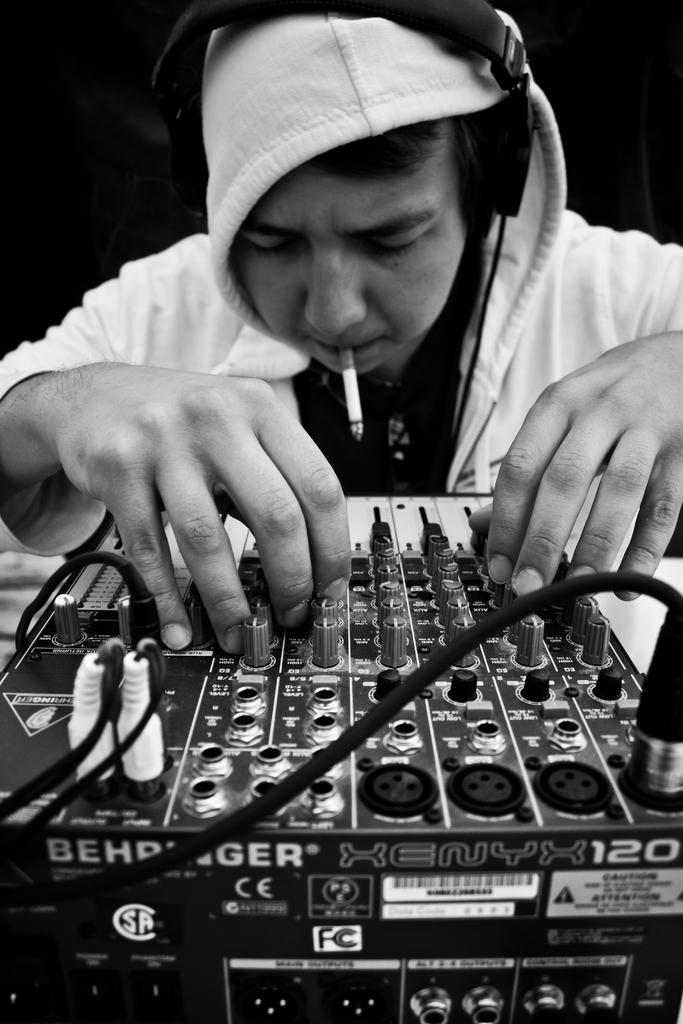What is the main subject of the image? There is a person in the image. What is the person doing in the image? The person is mixing music on an electronic device. Can you describe any additional details about the person? The person has a cigarette in his mouth. What type of orange can be seen in the image? There is no orange present in the image. How does the person's music attract the attention of others in the image? The image does not show the person's music attracting the attention of others, nor does it provide any information about the music's effect on others. 